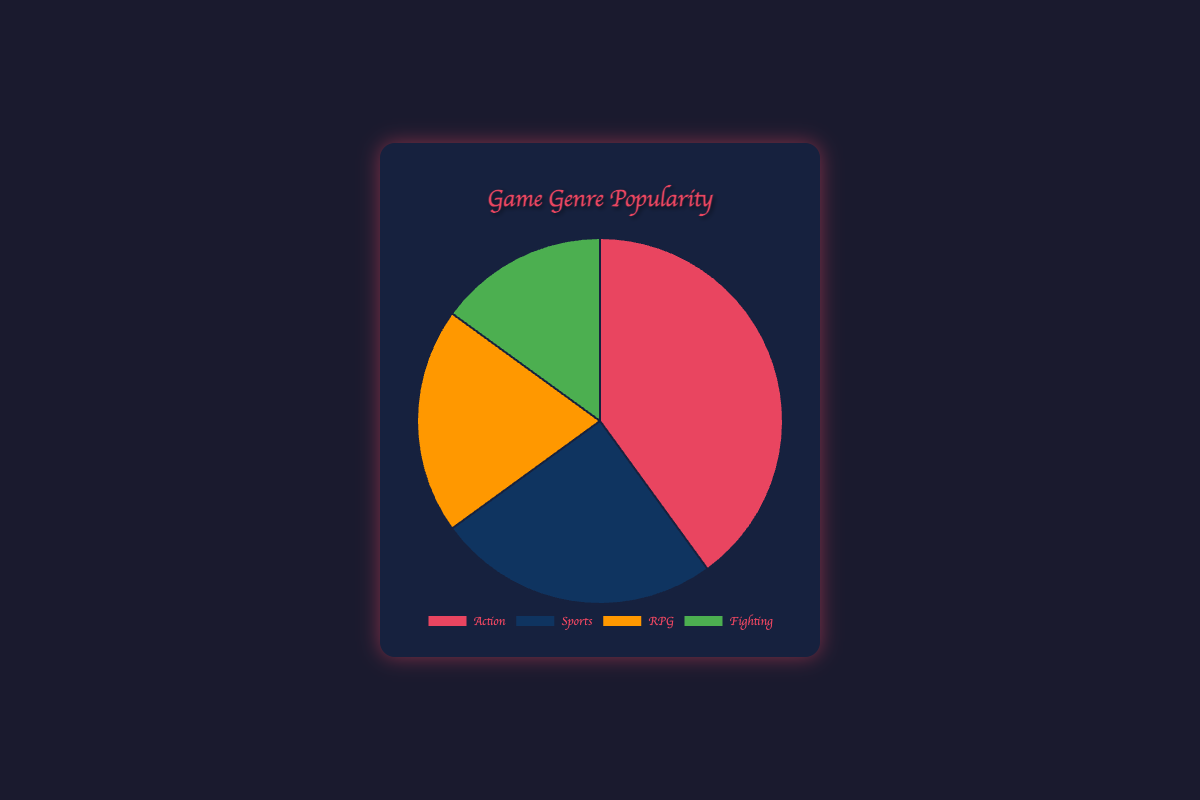What percentage of participants prefer Action games? The chart shows the proportion of each game genre preferred by participants. The Action segment occupies 40% of the pie chart.
Answer: 40% Which genre is the least popular among participants? From the pie chart, the segment for Fighting games is the smallest, indicating the least number of participants prefer this genre.
Answer: Fighting What is the combined percentage of participants who prefer RPG and Fighting games? According to the chart, RPG accounts for 20% and Fighting accounts for 15%. Adding these together: 20% + 15% = 35%.
Answer: 35% Are there more participants that prefer Sports or RPG games? The pie chart shows that Sports have a 25% share, while RPG has a 20% share. Since 25% is greater than 20%, more participants prefer Sports.
Answer: Sports Which genre is represented by the green segment of the pie chart? The chart uses color coding, and the green segment represents Fighting games.
Answer: Fighting What is the percentage difference between participants who prefer Action games and those who prefer Sports games? From the chart, Action is 40% and Sports is 25%. The percentage difference is 40% - 25% = 15%.
Answer: 15% If half of the participants who prefer Action games switched to RPG games, what would be the new percentage of RPG participants? Initially, RPG is 20%, and Action is 40%. Half of Action (40% / 2) would be 20%. Adding this to RPG: 20% (initial) + 20% (new) = 40%.
Answer: 40% How much larger is the combined percentage of participants who prefer Action and Sports games compared to those who prefer RPG games? Action is 40%, and Sports is 25%. Combined: 40% + 25% = 65%. RPG is 20%. Difference: 65% - 20% = 45%.
Answer: 45% What proportion of participants do not prefer Action games? Action accounts for 40%, so participants who do not prefer Action make up 100% - 40% = 60%.
Answer: 60% 